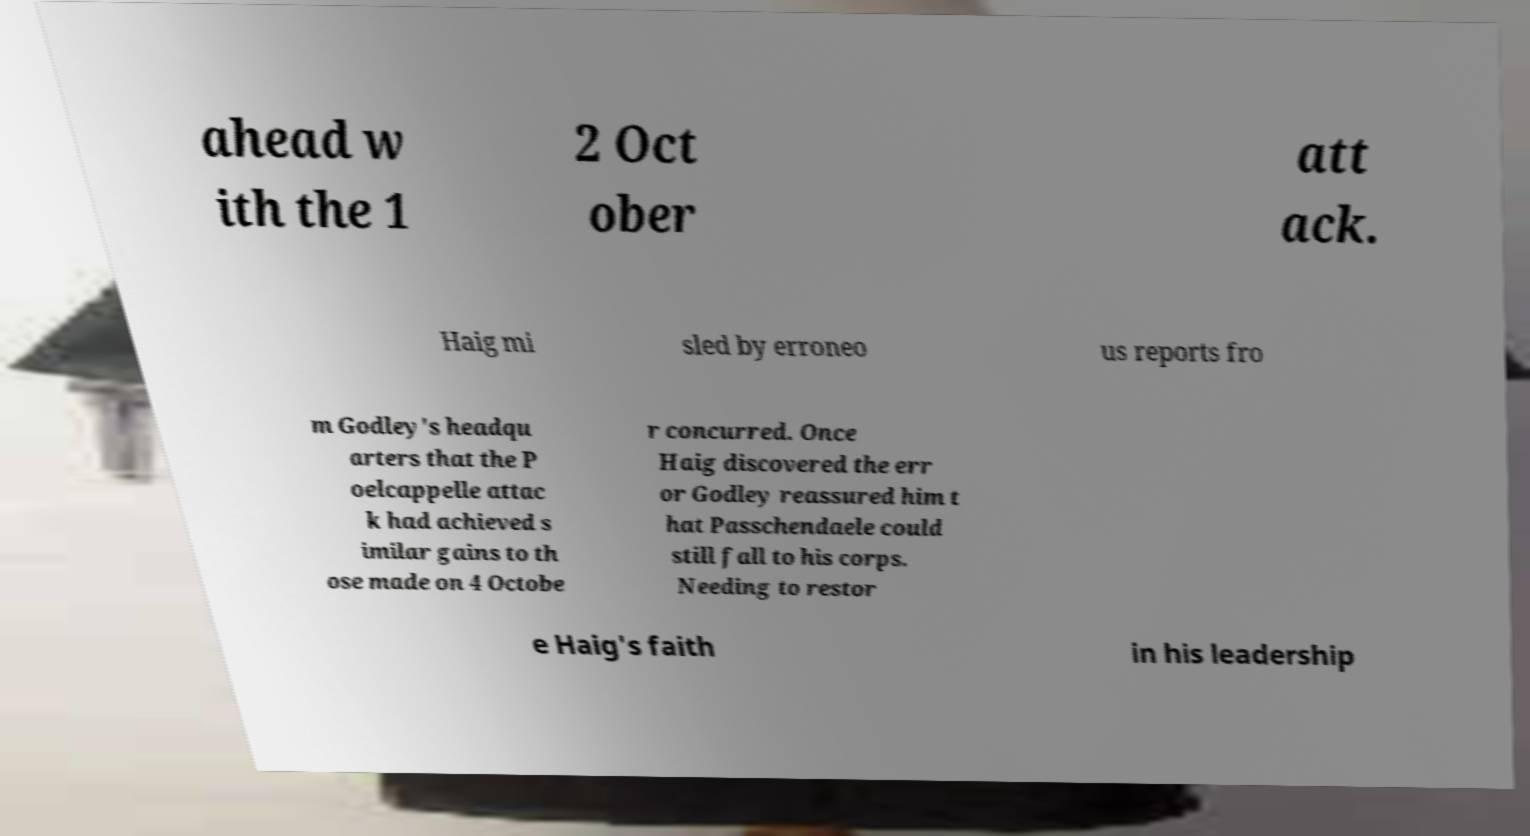What messages or text are displayed in this image? I need them in a readable, typed format. ahead w ith the 1 2 Oct ober att ack. Haig mi sled by erroneo us reports fro m Godley's headqu arters that the P oelcappelle attac k had achieved s imilar gains to th ose made on 4 Octobe r concurred. Once Haig discovered the err or Godley reassured him t hat Passchendaele could still fall to his corps. Needing to restor e Haig's faith in his leadership 